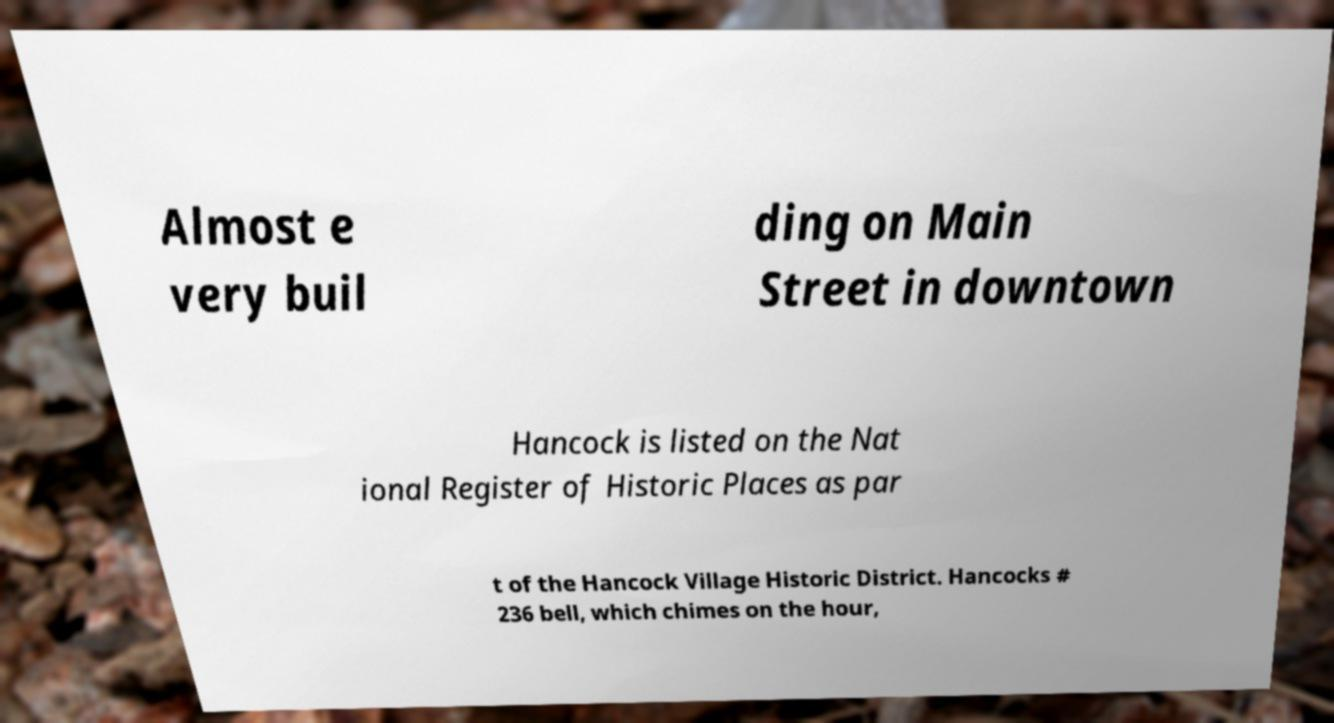Can you accurately transcribe the text from the provided image for me? Almost e very buil ding on Main Street in downtown Hancock is listed on the Nat ional Register of Historic Places as par t of the Hancock Village Historic District. Hancocks # 236 bell, which chimes on the hour, 